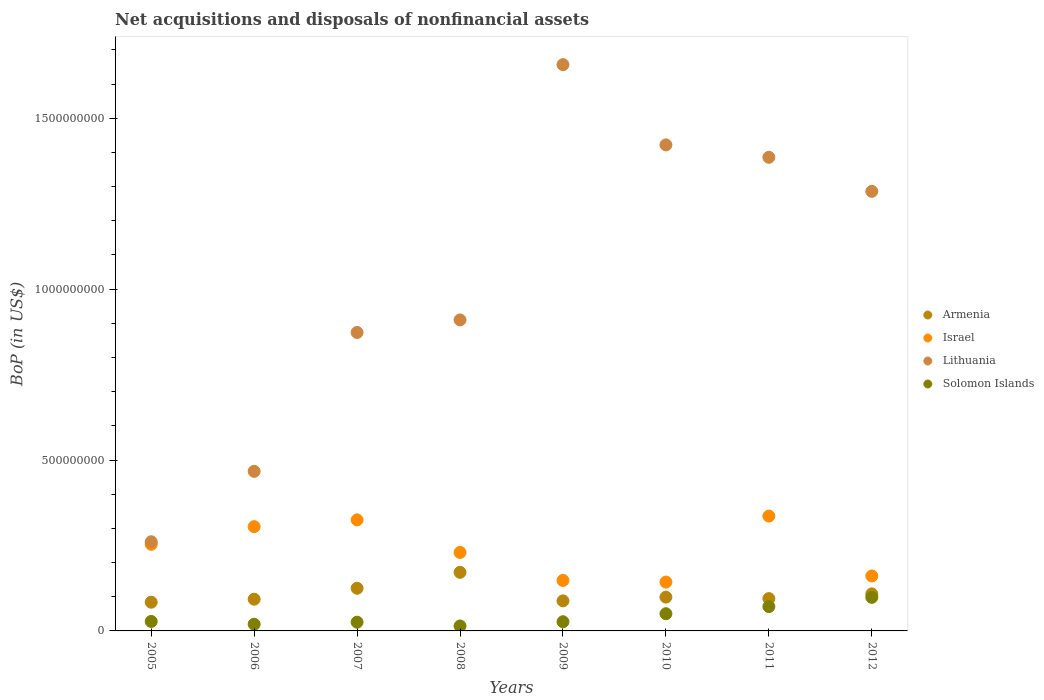What is the Balance of Payments in Solomon Islands in 2006?
Make the answer very short. 1.95e+07. Across all years, what is the maximum Balance of Payments in Armenia?
Your answer should be compact. 1.71e+08. Across all years, what is the minimum Balance of Payments in Lithuania?
Offer a very short reply. 2.61e+08. In which year was the Balance of Payments in Solomon Islands minimum?
Ensure brevity in your answer.  2008. What is the total Balance of Payments in Lithuania in the graph?
Provide a short and direct response. 8.26e+09. What is the difference between the Balance of Payments in Armenia in 2010 and that in 2011?
Offer a terse response. 4.26e+06. What is the difference between the Balance of Payments in Armenia in 2009 and the Balance of Payments in Solomon Islands in 2010?
Your answer should be compact. 3.76e+07. What is the average Balance of Payments in Lithuania per year?
Your answer should be very brief. 1.03e+09. In the year 2011, what is the difference between the Balance of Payments in Israel and Balance of Payments in Lithuania?
Provide a short and direct response. -1.05e+09. What is the ratio of the Balance of Payments in Armenia in 2009 to that in 2010?
Provide a succinct answer. 0.89. Is the Balance of Payments in Israel in 2009 less than that in 2011?
Provide a short and direct response. Yes. Is the difference between the Balance of Payments in Israel in 2007 and 2012 greater than the difference between the Balance of Payments in Lithuania in 2007 and 2012?
Make the answer very short. Yes. What is the difference between the highest and the second highest Balance of Payments in Armenia?
Your answer should be very brief. 4.66e+07. What is the difference between the highest and the lowest Balance of Payments in Israel?
Provide a succinct answer. 1.93e+08. Is it the case that in every year, the sum of the Balance of Payments in Lithuania and Balance of Payments in Solomon Islands  is greater than the sum of Balance of Payments in Israel and Balance of Payments in Armenia?
Provide a succinct answer. No. Is it the case that in every year, the sum of the Balance of Payments in Solomon Islands and Balance of Payments in Lithuania  is greater than the Balance of Payments in Israel?
Make the answer very short. Yes. Is the Balance of Payments in Solomon Islands strictly greater than the Balance of Payments in Armenia over the years?
Give a very brief answer. No. Is the Balance of Payments in Solomon Islands strictly less than the Balance of Payments in Israel over the years?
Keep it short and to the point. Yes. How many dotlines are there?
Give a very brief answer. 4. Are the values on the major ticks of Y-axis written in scientific E-notation?
Your response must be concise. No. What is the title of the graph?
Your answer should be compact. Net acquisitions and disposals of nonfinancial assets. Does "Turks and Caicos Islands" appear as one of the legend labels in the graph?
Keep it short and to the point. No. What is the label or title of the Y-axis?
Your answer should be very brief. BoP (in US$). What is the BoP (in US$) in Armenia in 2005?
Give a very brief answer. 8.40e+07. What is the BoP (in US$) of Israel in 2005?
Keep it short and to the point. 2.53e+08. What is the BoP (in US$) in Lithuania in 2005?
Provide a succinct answer. 2.61e+08. What is the BoP (in US$) of Solomon Islands in 2005?
Keep it short and to the point. 2.77e+07. What is the BoP (in US$) of Armenia in 2006?
Provide a succinct answer. 9.28e+07. What is the BoP (in US$) of Israel in 2006?
Your answer should be compact. 3.05e+08. What is the BoP (in US$) of Lithuania in 2006?
Your answer should be compact. 4.67e+08. What is the BoP (in US$) in Solomon Islands in 2006?
Keep it short and to the point. 1.95e+07. What is the BoP (in US$) of Armenia in 2007?
Ensure brevity in your answer.  1.25e+08. What is the BoP (in US$) of Israel in 2007?
Provide a short and direct response. 3.25e+08. What is the BoP (in US$) in Lithuania in 2007?
Provide a succinct answer. 8.73e+08. What is the BoP (in US$) of Solomon Islands in 2007?
Make the answer very short. 2.56e+07. What is the BoP (in US$) of Armenia in 2008?
Ensure brevity in your answer.  1.71e+08. What is the BoP (in US$) in Israel in 2008?
Your response must be concise. 2.30e+08. What is the BoP (in US$) in Lithuania in 2008?
Provide a succinct answer. 9.10e+08. What is the BoP (in US$) in Solomon Islands in 2008?
Your answer should be compact. 1.45e+07. What is the BoP (in US$) of Armenia in 2009?
Make the answer very short. 8.79e+07. What is the BoP (in US$) in Israel in 2009?
Offer a terse response. 1.48e+08. What is the BoP (in US$) in Lithuania in 2009?
Offer a very short reply. 1.66e+09. What is the BoP (in US$) in Solomon Islands in 2009?
Keep it short and to the point. 2.68e+07. What is the BoP (in US$) of Armenia in 2010?
Give a very brief answer. 9.89e+07. What is the BoP (in US$) of Israel in 2010?
Offer a terse response. 1.43e+08. What is the BoP (in US$) in Lithuania in 2010?
Give a very brief answer. 1.42e+09. What is the BoP (in US$) in Solomon Islands in 2010?
Provide a short and direct response. 5.03e+07. What is the BoP (in US$) of Armenia in 2011?
Your answer should be compact. 9.46e+07. What is the BoP (in US$) in Israel in 2011?
Your answer should be compact. 3.36e+08. What is the BoP (in US$) of Lithuania in 2011?
Make the answer very short. 1.39e+09. What is the BoP (in US$) in Solomon Islands in 2011?
Your answer should be very brief. 7.12e+07. What is the BoP (in US$) in Armenia in 2012?
Provide a succinct answer. 1.08e+08. What is the BoP (in US$) of Israel in 2012?
Keep it short and to the point. 1.61e+08. What is the BoP (in US$) in Lithuania in 2012?
Make the answer very short. 1.29e+09. What is the BoP (in US$) of Solomon Islands in 2012?
Offer a terse response. 9.82e+07. Across all years, what is the maximum BoP (in US$) of Armenia?
Your answer should be compact. 1.71e+08. Across all years, what is the maximum BoP (in US$) of Israel?
Your response must be concise. 3.36e+08. Across all years, what is the maximum BoP (in US$) of Lithuania?
Offer a terse response. 1.66e+09. Across all years, what is the maximum BoP (in US$) of Solomon Islands?
Keep it short and to the point. 9.82e+07. Across all years, what is the minimum BoP (in US$) in Armenia?
Make the answer very short. 8.40e+07. Across all years, what is the minimum BoP (in US$) of Israel?
Give a very brief answer. 1.43e+08. Across all years, what is the minimum BoP (in US$) in Lithuania?
Offer a terse response. 2.61e+08. Across all years, what is the minimum BoP (in US$) of Solomon Islands?
Your answer should be compact. 1.45e+07. What is the total BoP (in US$) in Armenia in the graph?
Your response must be concise. 8.63e+08. What is the total BoP (in US$) of Israel in the graph?
Ensure brevity in your answer.  1.90e+09. What is the total BoP (in US$) in Lithuania in the graph?
Make the answer very short. 8.26e+09. What is the total BoP (in US$) in Solomon Islands in the graph?
Your answer should be very brief. 3.34e+08. What is the difference between the BoP (in US$) of Armenia in 2005 and that in 2006?
Your answer should be compact. -8.81e+06. What is the difference between the BoP (in US$) of Israel in 2005 and that in 2006?
Offer a very short reply. -5.17e+07. What is the difference between the BoP (in US$) of Lithuania in 2005 and that in 2006?
Your answer should be very brief. -2.06e+08. What is the difference between the BoP (in US$) in Solomon Islands in 2005 and that in 2006?
Offer a very short reply. 8.20e+06. What is the difference between the BoP (in US$) in Armenia in 2005 and that in 2007?
Provide a short and direct response. -4.08e+07. What is the difference between the BoP (in US$) in Israel in 2005 and that in 2007?
Provide a short and direct response. -7.15e+07. What is the difference between the BoP (in US$) in Lithuania in 2005 and that in 2007?
Make the answer very short. -6.12e+08. What is the difference between the BoP (in US$) in Solomon Islands in 2005 and that in 2007?
Offer a terse response. 2.14e+06. What is the difference between the BoP (in US$) of Armenia in 2005 and that in 2008?
Your answer should be compact. -8.74e+07. What is the difference between the BoP (in US$) in Israel in 2005 and that in 2008?
Offer a terse response. 2.38e+07. What is the difference between the BoP (in US$) in Lithuania in 2005 and that in 2008?
Your response must be concise. -6.49e+08. What is the difference between the BoP (in US$) of Solomon Islands in 2005 and that in 2008?
Keep it short and to the point. 1.32e+07. What is the difference between the BoP (in US$) in Armenia in 2005 and that in 2009?
Offer a very short reply. -3.88e+06. What is the difference between the BoP (in US$) of Israel in 2005 and that in 2009?
Make the answer very short. 1.06e+08. What is the difference between the BoP (in US$) of Lithuania in 2005 and that in 2009?
Make the answer very short. -1.40e+09. What is the difference between the BoP (in US$) in Solomon Islands in 2005 and that in 2009?
Your answer should be compact. 8.91e+05. What is the difference between the BoP (in US$) of Armenia in 2005 and that in 2010?
Ensure brevity in your answer.  -1.49e+07. What is the difference between the BoP (in US$) of Israel in 2005 and that in 2010?
Give a very brief answer. 1.10e+08. What is the difference between the BoP (in US$) in Lithuania in 2005 and that in 2010?
Make the answer very short. -1.16e+09. What is the difference between the BoP (in US$) in Solomon Islands in 2005 and that in 2010?
Provide a succinct answer. -2.26e+07. What is the difference between the BoP (in US$) of Armenia in 2005 and that in 2011?
Your response must be concise. -1.06e+07. What is the difference between the BoP (in US$) of Israel in 2005 and that in 2011?
Your answer should be very brief. -8.26e+07. What is the difference between the BoP (in US$) of Lithuania in 2005 and that in 2011?
Make the answer very short. -1.12e+09. What is the difference between the BoP (in US$) of Solomon Islands in 2005 and that in 2011?
Give a very brief answer. -4.35e+07. What is the difference between the BoP (in US$) of Armenia in 2005 and that in 2012?
Offer a very short reply. -2.44e+07. What is the difference between the BoP (in US$) in Israel in 2005 and that in 2012?
Provide a succinct answer. 9.26e+07. What is the difference between the BoP (in US$) of Lithuania in 2005 and that in 2012?
Provide a short and direct response. -1.03e+09. What is the difference between the BoP (in US$) in Solomon Islands in 2005 and that in 2012?
Make the answer very short. -7.05e+07. What is the difference between the BoP (in US$) of Armenia in 2006 and that in 2007?
Give a very brief answer. -3.20e+07. What is the difference between the BoP (in US$) in Israel in 2006 and that in 2007?
Your response must be concise. -1.98e+07. What is the difference between the BoP (in US$) of Lithuania in 2006 and that in 2007?
Your answer should be very brief. -4.06e+08. What is the difference between the BoP (in US$) of Solomon Islands in 2006 and that in 2007?
Provide a short and direct response. -6.06e+06. What is the difference between the BoP (in US$) of Armenia in 2006 and that in 2008?
Keep it short and to the point. -7.86e+07. What is the difference between the BoP (in US$) in Israel in 2006 and that in 2008?
Keep it short and to the point. 7.55e+07. What is the difference between the BoP (in US$) of Lithuania in 2006 and that in 2008?
Your answer should be compact. -4.43e+08. What is the difference between the BoP (in US$) of Solomon Islands in 2006 and that in 2008?
Your response must be concise. 5.03e+06. What is the difference between the BoP (in US$) in Armenia in 2006 and that in 2009?
Provide a short and direct response. 4.93e+06. What is the difference between the BoP (in US$) of Israel in 2006 and that in 2009?
Offer a very short reply. 1.57e+08. What is the difference between the BoP (in US$) in Lithuania in 2006 and that in 2009?
Your response must be concise. -1.19e+09. What is the difference between the BoP (in US$) of Solomon Islands in 2006 and that in 2009?
Provide a succinct answer. -7.31e+06. What is the difference between the BoP (in US$) of Armenia in 2006 and that in 2010?
Make the answer very short. -6.05e+06. What is the difference between the BoP (in US$) of Israel in 2006 and that in 2010?
Keep it short and to the point. 1.62e+08. What is the difference between the BoP (in US$) of Lithuania in 2006 and that in 2010?
Ensure brevity in your answer.  -9.55e+08. What is the difference between the BoP (in US$) in Solomon Islands in 2006 and that in 2010?
Keep it short and to the point. -3.08e+07. What is the difference between the BoP (in US$) of Armenia in 2006 and that in 2011?
Provide a succinct answer. -1.79e+06. What is the difference between the BoP (in US$) in Israel in 2006 and that in 2011?
Offer a terse response. -3.09e+07. What is the difference between the BoP (in US$) of Lithuania in 2006 and that in 2011?
Your answer should be compact. -9.19e+08. What is the difference between the BoP (in US$) of Solomon Islands in 2006 and that in 2011?
Ensure brevity in your answer.  -5.17e+07. What is the difference between the BoP (in US$) in Armenia in 2006 and that in 2012?
Ensure brevity in your answer.  -1.56e+07. What is the difference between the BoP (in US$) in Israel in 2006 and that in 2012?
Ensure brevity in your answer.  1.44e+08. What is the difference between the BoP (in US$) in Lithuania in 2006 and that in 2012?
Your response must be concise. -8.19e+08. What is the difference between the BoP (in US$) of Solomon Islands in 2006 and that in 2012?
Provide a short and direct response. -7.87e+07. What is the difference between the BoP (in US$) of Armenia in 2007 and that in 2008?
Your answer should be compact. -4.66e+07. What is the difference between the BoP (in US$) of Israel in 2007 and that in 2008?
Keep it short and to the point. 9.53e+07. What is the difference between the BoP (in US$) of Lithuania in 2007 and that in 2008?
Keep it short and to the point. -3.67e+07. What is the difference between the BoP (in US$) in Solomon Islands in 2007 and that in 2008?
Your response must be concise. 1.11e+07. What is the difference between the BoP (in US$) of Armenia in 2007 and that in 2009?
Your answer should be very brief. 3.70e+07. What is the difference between the BoP (in US$) in Israel in 2007 and that in 2009?
Offer a terse response. 1.77e+08. What is the difference between the BoP (in US$) in Lithuania in 2007 and that in 2009?
Offer a very short reply. -7.84e+08. What is the difference between the BoP (in US$) of Solomon Islands in 2007 and that in 2009?
Your response must be concise. -1.24e+06. What is the difference between the BoP (in US$) in Armenia in 2007 and that in 2010?
Provide a short and direct response. 2.60e+07. What is the difference between the BoP (in US$) in Israel in 2007 and that in 2010?
Keep it short and to the point. 1.82e+08. What is the difference between the BoP (in US$) of Lithuania in 2007 and that in 2010?
Provide a succinct answer. -5.49e+08. What is the difference between the BoP (in US$) of Solomon Islands in 2007 and that in 2010?
Ensure brevity in your answer.  -2.47e+07. What is the difference between the BoP (in US$) of Armenia in 2007 and that in 2011?
Ensure brevity in your answer.  3.02e+07. What is the difference between the BoP (in US$) of Israel in 2007 and that in 2011?
Provide a short and direct response. -1.11e+07. What is the difference between the BoP (in US$) of Lithuania in 2007 and that in 2011?
Your response must be concise. -5.12e+08. What is the difference between the BoP (in US$) in Solomon Islands in 2007 and that in 2011?
Offer a very short reply. -4.56e+07. What is the difference between the BoP (in US$) of Armenia in 2007 and that in 2012?
Your answer should be very brief. 1.64e+07. What is the difference between the BoP (in US$) in Israel in 2007 and that in 2012?
Make the answer very short. 1.64e+08. What is the difference between the BoP (in US$) in Lithuania in 2007 and that in 2012?
Ensure brevity in your answer.  -4.13e+08. What is the difference between the BoP (in US$) in Solomon Islands in 2007 and that in 2012?
Offer a very short reply. -7.26e+07. What is the difference between the BoP (in US$) of Armenia in 2008 and that in 2009?
Your answer should be very brief. 8.36e+07. What is the difference between the BoP (in US$) of Israel in 2008 and that in 2009?
Your response must be concise. 8.19e+07. What is the difference between the BoP (in US$) in Lithuania in 2008 and that in 2009?
Make the answer very short. -7.47e+08. What is the difference between the BoP (in US$) in Solomon Islands in 2008 and that in 2009?
Your response must be concise. -1.23e+07. What is the difference between the BoP (in US$) in Armenia in 2008 and that in 2010?
Give a very brief answer. 7.26e+07. What is the difference between the BoP (in US$) of Israel in 2008 and that in 2010?
Your response must be concise. 8.67e+07. What is the difference between the BoP (in US$) in Lithuania in 2008 and that in 2010?
Make the answer very short. -5.12e+08. What is the difference between the BoP (in US$) of Solomon Islands in 2008 and that in 2010?
Provide a succinct answer. -3.58e+07. What is the difference between the BoP (in US$) of Armenia in 2008 and that in 2011?
Provide a short and direct response. 7.68e+07. What is the difference between the BoP (in US$) of Israel in 2008 and that in 2011?
Offer a very short reply. -1.06e+08. What is the difference between the BoP (in US$) in Lithuania in 2008 and that in 2011?
Provide a short and direct response. -4.76e+08. What is the difference between the BoP (in US$) in Solomon Islands in 2008 and that in 2011?
Offer a terse response. -5.67e+07. What is the difference between the BoP (in US$) of Armenia in 2008 and that in 2012?
Your answer should be compact. 6.30e+07. What is the difference between the BoP (in US$) of Israel in 2008 and that in 2012?
Provide a succinct answer. 6.88e+07. What is the difference between the BoP (in US$) in Lithuania in 2008 and that in 2012?
Keep it short and to the point. -3.76e+08. What is the difference between the BoP (in US$) in Solomon Islands in 2008 and that in 2012?
Make the answer very short. -8.37e+07. What is the difference between the BoP (in US$) in Armenia in 2009 and that in 2010?
Provide a short and direct response. -1.10e+07. What is the difference between the BoP (in US$) of Israel in 2009 and that in 2010?
Ensure brevity in your answer.  4.80e+06. What is the difference between the BoP (in US$) of Lithuania in 2009 and that in 2010?
Your response must be concise. 2.35e+08. What is the difference between the BoP (in US$) of Solomon Islands in 2009 and that in 2010?
Give a very brief answer. -2.35e+07. What is the difference between the BoP (in US$) in Armenia in 2009 and that in 2011?
Provide a short and direct response. -6.72e+06. What is the difference between the BoP (in US$) of Israel in 2009 and that in 2011?
Provide a succinct answer. -1.88e+08. What is the difference between the BoP (in US$) of Lithuania in 2009 and that in 2011?
Ensure brevity in your answer.  2.71e+08. What is the difference between the BoP (in US$) in Solomon Islands in 2009 and that in 2011?
Make the answer very short. -4.44e+07. What is the difference between the BoP (in US$) in Armenia in 2009 and that in 2012?
Provide a succinct answer. -2.05e+07. What is the difference between the BoP (in US$) in Israel in 2009 and that in 2012?
Offer a very short reply. -1.31e+07. What is the difference between the BoP (in US$) of Lithuania in 2009 and that in 2012?
Give a very brief answer. 3.71e+08. What is the difference between the BoP (in US$) of Solomon Islands in 2009 and that in 2012?
Your response must be concise. -7.14e+07. What is the difference between the BoP (in US$) of Armenia in 2010 and that in 2011?
Your answer should be very brief. 4.26e+06. What is the difference between the BoP (in US$) of Israel in 2010 and that in 2011?
Keep it short and to the point. -1.93e+08. What is the difference between the BoP (in US$) of Lithuania in 2010 and that in 2011?
Offer a very short reply. 3.64e+07. What is the difference between the BoP (in US$) in Solomon Islands in 2010 and that in 2011?
Give a very brief answer. -2.09e+07. What is the difference between the BoP (in US$) in Armenia in 2010 and that in 2012?
Give a very brief answer. -9.55e+06. What is the difference between the BoP (in US$) in Israel in 2010 and that in 2012?
Your answer should be compact. -1.79e+07. What is the difference between the BoP (in US$) in Lithuania in 2010 and that in 2012?
Your answer should be very brief. 1.36e+08. What is the difference between the BoP (in US$) in Solomon Islands in 2010 and that in 2012?
Offer a terse response. -4.79e+07. What is the difference between the BoP (in US$) of Armenia in 2011 and that in 2012?
Make the answer very short. -1.38e+07. What is the difference between the BoP (in US$) of Israel in 2011 and that in 2012?
Your answer should be very brief. 1.75e+08. What is the difference between the BoP (in US$) in Lithuania in 2011 and that in 2012?
Your answer should be very brief. 9.96e+07. What is the difference between the BoP (in US$) in Solomon Islands in 2011 and that in 2012?
Provide a succinct answer. -2.70e+07. What is the difference between the BoP (in US$) of Armenia in 2005 and the BoP (in US$) of Israel in 2006?
Your answer should be compact. -2.21e+08. What is the difference between the BoP (in US$) in Armenia in 2005 and the BoP (in US$) in Lithuania in 2006?
Your answer should be very brief. -3.83e+08. What is the difference between the BoP (in US$) of Armenia in 2005 and the BoP (in US$) of Solomon Islands in 2006?
Keep it short and to the point. 6.45e+07. What is the difference between the BoP (in US$) of Israel in 2005 and the BoP (in US$) of Lithuania in 2006?
Give a very brief answer. -2.14e+08. What is the difference between the BoP (in US$) in Israel in 2005 and the BoP (in US$) in Solomon Islands in 2006?
Offer a very short reply. 2.34e+08. What is the difference between the BoP (in US$) in Lithuania in 2005 and the BoP (in US$) in Solomon Islands in 2006?
Ensure brevity in your answer.  2.41e+08. What is the difference between the BoP (in US$) of Armenia in 2005 and the BoP (in US$) of Israel in 2007?
Make the answer very short. -2.41e+08. What is the difference between the BoP (in US$) in Armenia in 2005 and the BoP (in US$) in Lithuania in 2007?
Provide a succinct answer. -7.89e+08. What is the difference between the BoP (in US$) in Armenia in 2005 and the BoP (in US$) in Solomon Islands in 2007?
Provide a succinct answer. 5.84e+07. What is the difference between the BoP (in US$) in Israel in 2005 and the BoP (in US$) in Lithuania in 2007?
Give a very brief answer. -6.20e+08. What is the difference between the BoP (in US$) in Israel in 2005 and the BoP (in US$) in Solomon Islands in 2007?
Ensure brevity in your answer.  2.28e+08. What is the difference between the BoP (in US$) of Lithuania in 2005 and the BoP (in US$) of Solomon Islands in 2007?
Give a very brief answer. 2.35e+08. What is the difference between the BoP (in US$) in Armenia in 2005 and the BoP (in US$) in Israel in 2008?
Keep it short and to the point. -1.46e+08. What is the difference between the BoP (in US$) in Armenia in 2005 and the BoP (in US$) in Lithuania in 2008?
Your answer should be very brief. -8.26e+08. What is the difference between the BoP (in US$) of Armenia in 2005 and the BoP (in US$) of Solomon Islands in 2008?
Provide a short and direct response. 6.95e+07. What is the difference between the BoP (in US$) of Israel in 2005 and the BoP (in US$) of Lithuania in 2008?
Your answer should be compact. -6.57e+08. What is the difference between the BoP (in US$) in Israel in 2005 and the BoP (in US$) in Solomon Islands in 2008?
Give a very brief answer. 2.39e+08. What is the difference between the BoP (in US$) of Lithuania in 2005 and the BoP (in US$) of Solomon Islands in 2008?
Give a very brief answer. 2.46e+08. What is the difference between the BoP (in US$) in Armenia in 2005 and the BoP (in US$) in Israel in 2009?
Ensure brevity in your answer.  -6.37e+07. What is the difference between the BoP (in US$) in Armenia in 2005 and the BoP (in US$) in Lithuania in 2009?
Your answer should be compact. -1.57e+09. What is the difference between the BoP (in US$) in Armenia in 2005 and the BoP (in US$) in Solomon Islands in 2009?
Provide a short and direct response. 5.72e+07. What is the difference between the BoP (in US$) of Israel in 2005 and the BoP (in US$) of Lithuania in 2009?
Provide a succinct answer. -1.40e+09. What is the difference between the BoP (in US$) of Israel in 2005 and the BoP (in US$) of Solomon Islands in 2009?
Give a very brief answer. 2.27e+08. What is the difference between the BoP (in US$) of Lithuania in 2005 and the BoP (in US$) of Solomon Islands in 2009?
Provide a short and direct response. 2.34e+08. What is the difference between the BoP (in US$) in Armenia in 2005 and the BoP (in US$) in Israel in 2010?
Your response must be concise. -5.89e+07. What is the difference between the BoP (in US$) in Armenia in 2005 and the BoP (in US$) in Lithuania in 2010?
Give a very brief answer. -1.34e+09. What is the difference between the BoP (in US$) of Armenia in 2005 and the BoP (in US$) of Solomon Islands in 2010?
Offer a very short reply. 3.37e+07. What is the difference between the BoP (in US$) of Israel in 2005 and the BoP (in US$) of Lithuania in 2010?
Provide a succinct answer. -1.17e+09. What is the difference between the BoP (in US$) in Israel in 2005 and the BoP (in US$) in Solomon Islands in 2010?
Ensure brevity in your answer.  2.03e+08. What is the difference between the BoP (in US$) in Lithuania in 2005 and the BoP (in US$) in Solomon Islands in 2010?
Your response must be concise. 2.11e+08. What is the difference between the BoP (in US$) of Armenia in 2005 and the BoP (in US$) of Israel in 2011?
Offer a terse response. -2.52e+08. What is the difference between the BoP (in US$) of Armenia in 2005 and the BoP (in US$) of Lithuania in 2011?
Offer a very short reply. -1.30e+09. What is the difference between the BoP (in US$) of Armenia in 2005 and the BoP (in US$) of Solomon Islands in 2011?
Offer a very short reply. 1.28e+07. What is the difference between the BoP (in US$) of Israel in 2005 and the BoP (in US$) of Lithuania in 2011?
Provide a short and direct response. -1.13e+09. What is the difference between the BoP (in US$) of Israel in 2005 and the BoP (in US$) of Solomon Islands in 2011?
Keep it short and to the point. 1.82e+08. What is the difference between the BoP (in US$) in Lithuania in 2005 and the BoP (in US$) in Solomon Islands in 2011?
Offer a terse response. 1.90e+08. What is the difference between the BoP (in US$) in Armenia in 2005 and the BoP (in US$) in Israel in 2012?
Provide a succinct answer. -7.68e+07. What is the difference between the BoP (in US$) of Armenia in 2005 and the BoP (in US$) of Lithuania in 2012?
Your answer should be very brief. -1.20e+09. What is the difference between the BoP (in US$) of Armenia in 2005 and the BoP (in US$) of Solomon Islands in 2012?
Provide a succinct answer. -1.42e+07. What is the difference between the BoP (in US$) of Israel in 2005 and the BoP (in US$) of Lithuania in 2012?
Your answer should be compact. -1.03e+09. What is the difference between the BoP (in US$) in Israel in 2005 and the BoP (in US$) in Solomon Islands in 2012?
Give a very brief answer. 1.55e+08. What is the difference between the BoP (in US$) in Lithuania in 2005 and the BoP (in US$) in Solomon Islands in 2012?
Make the answer very short. 1.63e+08. What is the difference between the BoP (in US$) in Armenia in 2006 and the BoP (in US$) in Israel in 2007?
Provide a succinct answer. -2.32e+08. What is the difference between the BoP (in US$) in Armenia in 2006 and the BoP (in US$) in Lithuania in 2007?
Your answer should be very brief. -7.80e+08. What is the difference between the BoP (in US$) of Armenia in 2006 and the BoP (in US$) of Solomon Islands in 2007?
Offer a very short reply. 6.72e+07. What is the difference between the BoP (in US$) in Israel in 2006 and the BoP (in US$) in Lithuania in 2007?
Offer a terse response. -5.68e+08. What is the difference between the BoP (in US$) in Israel in 2006 and the BoP (in US$) in Solomon Islands in 2007?
Ensure brevity in your answer.  2.80e+08. What is the difference between the BoP (in US$) of Lithuania in 2006 and the BoP (in US$) of Solomon Islands in 2007?
Ensure brevity in your answer.  4.41e+08. What is the difference between the BoP (in US$) in Armenia in 2006 and the BoP (in US$) in Israel in 2008?
Make the answer very short. -1.37e+08. What is the difference between the BoP (in US$) in Armenia in 2006 and the BoP (in US$) in Lithuania in 2008?
Your response must be concise. -8.17e+08. What is the difference between the BoP (in US$) in Armenia in 2006 and the BoP (in US$) in Solomon Islands in 2008?
Your answer should be compact. 7.83e+07. What is the difference between the BoP (in US$) of Israel in 2006 and the BoP (in US$) of Lithuania in 2008?
Your answer should be compact. -6.05e+08. What is the difference between the BoP (in US$) in Israel in 2006 and the BoP (in US$) in Solomon Islands in 2008?
Provide a short and direct response. 2.91e+08. What is the difference between the BoP (in US$) in Lithuania in 2006 and the BoP (in US$) in Solomon Islands in 2008?
Make the answer very short. 4.52e+08. What is the difference between the BoP (in US$) of Armenia in 2006 and the BoP (in US$) of Israel in 2009?
Provide a succinct answer. -5.49e+07. What is the difference between the BoP (in US$) in Armenia in 2006 and the BoP (in US$) in Lithuania in 2009?
Keep it short and to the point. -1.56e+09. What is the difference between the BoP (in US$) in Armenia in 2006 and the BoP (in US$) in Solomon Islands in 2009?
Offer a very short reply. 6.60e+07. What is the difference between the BoP (in US$) of Israel in 2006 and the BoP (in US$) of Lithuania in 2009?
Your answer should be very brief. -1.35e+09. What is the difference between the BoP (in US$) of Israel in 2006 and the BoP (in US$) of Solomon Islands in 2009?
Keep it short and to the point. 2.78e+08. What is the difference between the BoP (in US$) in Lithuania in 2006 and the BoP (in US$) in Solomon Islands in 2009?
Offer a very short reply. 4.40e+08. What is the difference between the BoP (in US$) in Armenia in 2006 and the BoP (in US$) in Israel in 2010?
Provide a succinct answer. -5.01e+07. What is the difference between the BoP (in US$) of Armenia in 2006 and the BoP (in US$) of Lithuania in 2010?
Offer a terse response. -1.33e+09. What is the difference between the BoP (in US$) of Armenia in 2006 and the BoP (in US$) of Solomon Islands in 2010?
Make the answer very short. 4.25e+07. What is the difference between the BoP (in US$) of Israel in 2006 and the BoP (in US$) of Lithuania in 2010?
Your answer should be compact. -1.12e+09. What is the difference between the BoP (in US$) in Israel in 2006 and the BoP (in US$) in Solomon Islands in 2010?
Your answer should be compact. 2.55e+08. What is the difference between the BoP (in US$) of Lithuania in 2006 and the BoP (in US$) of Solomon Islands in 2010?
Keep it short and to the point. 4.17e+08. What is the difference between the BoP (in US$) of Armenia in 2006 and the BoP (in US$) of Israel in 2011?
Ensure brevity in your answer.  -2.43e+08. What is the difference between the BoP (in US$) in Armenia in 2006 and the BoP (in US$) in Lithuania in 2011?
Offer a terse response. -1.29e+09. What is the difference between the BoP (in US$) in Armenia in 2006 and the BoP (in US$) in Solomon Islands in 2011?
Your response must be concise. 2.16e+07. What is the difference between the BoP (in US$) in Israel in 2006 and the BoP (in US$) in Lithuania in 2011?
Your answer should be very brief. -1.08e+09. What is the difference between the BoP (in US$) in Israel in 2006 and the BoP (in US$) in Solomon Islands in 2011?
Your response must be concise. 2.34e+08. What is the difference between the BoP (in US$) of Lithuania in 2006 and the BoP (in US$) of Solomon Islands in 2011?
Offer a terse response. 3.96e+08. What is the difference between the BoP (in US$) in Armenia in 2006 and the BoP (in US$) in Israel in 2012?
Provide a succinct answer. -6.80e+07. What is the difference between the BoP (in US$) in Armenia in 2006 and the BoP (in US$) in Lithuania in 2012?
Your answer should be very brief. -1.19e+09. What is the difference between the BoP (in US$) of Armenia in 2006 and the BoP (in US$) of Solomon Islands in 2012?
Ensure brevity in your answer.  -5.39e+06. What is the difference between the BoP (in US$) of Israel in 2006 and the BoP (in US$) of Lithuania in 2012?
Give a very brief answer. -9.81e+08. What is the difference between the BoP (in US$) in Israel in 2006 and the BoP (in US$) in Solomon Islands in 2012?
Your response must be concise. 2.07e+08. What is the difference between the BoP (in US$) in Lithuania in 2006 and the BoP (in US$) in Solomon Islands in 2012?
Your answer should be compact. 3.69e+08. What is the difference between the BoP (in US$) of Armenia in 2007 and the BoP (in US$) of Israel in 2008?
Your answer should be compact. -1.05e+08. What is the difference between the BoP (in US$) in Armenia in 2007 and the BoP (in US$) in Lithuania in 2008?
Your answer should be very brief. -7.85e+08. What is the difference between the BoP (in US$) of Armenia in 2007 and the BoP (in US$) of Solomon Islands in 2008?
Give a very brief answer. 1.10e+08. What is the difference between the BoP (in US$) in Israel in 2007 and the BoP (in US$) in Lithuania in 2008?
Keep it short and to the point. -5.85e+08. What is the difference between the BoP (in US$) in Israel in 2007 and the BoP (in US$) in Solomon Islands in 2008?
Your response must be concise. 3.10e+08. What is the difference between the BoP (in US$) of Lithuania in 2007 and the BoP (in US$) of Solomon Islands in 2008?
Keep it short and to the point. 8.59e+08. What is the difference between the BoP (in US$) in Armenia in 2007 and the BoP (in US$) in Israel in 2009?
Your answer should be compact. -2.29e+07. What is the difference between the BoP (in US$) of Armenia in 2007 and the BoP (in US$) of Lithuania in 2009?
Provide a succinct answer. -1.53e+09. What is the difference between the BoP (in US$) in Armenia in 2007 and the BoP (in US$) in Solomon Islands in 2009?
Provide a short and direct response. 9.80e+07. What is the difference between the BoP (in US$) in Israel in 2007 and the BoP (in US$) in Lithuania in 2009?
Your answer should be compact. -1.33e+09. What is the difference between the BoP (in US$) of Israel in 2007 and the BoP (in US$) of Solomon Islands in 2009?
Keep it short and to the point. 2.98e+08. What is the difference between the BoP (in US$) in Lithuania in 2007 and the BoP (in US$) in Solomon Islands in 2009?
Provide a short and direct response. 8.46e+08. What is the difference between the BoP (in US$) in Armenia in 2007 and the BoP (in US$) in Israel in 2010?
Your answer should be very brief. -1.81e+07. What is the difference between the BoP (in US$) of Armenia in 2007 and the BoP (in US$) of Lithuania in 2010?
Ensure brevity in your answer.  -1.30e+09. What is the difference between the BoP (in US$) of Armenia in 2007 and the BoP (in US$) of Solomon Islands in 2010?
Keep it short and to the point. 7.45e+07. What is the difference between the BoP (in US$) of Israel in 2007 and the BoP (in US$) of Lithuania in 2010?
Offer a very short reply. -1.10e+09. What is the difference between the BoP (in US$) of Israel in 2007 and the BoP (in US$) of Solomon Islands in 2010?
Your response must be concise. 2.75e+08. What is the difference between the BoP (in US$) of Lithuania in 2007 and the BoP (in US$) of Solomon Islands in 2010?
Provide a short and direct response. 8.23e+08. What is the difference between the BoP (in US$) in Armenia in 2007 and the BoP (in US$) in Israel in 2011?
Your answer should be very brief. -2.11e+08. What is the difference between the BoP (in US$) in Armenia in 2007 and the BoP (in US$) in Lithuania in 2011?
Your answer should be compact. -1.26e+09. What is the difference between the BoP (in US$) in Armenia in 2007 and the BoP (in US$) in Solomon Islands in 2011?
Provide a succinct answer. 5.36e+07. What is the difference between the BoP (in US$) of Israel in 2007 and the BoP (in US$) of Lithuania in 2011?
Your response must be concise. -1.06e+09. What is the difference between the BoP (in US$) of Israel in 2007 and the BoP (in US$) of Solomon Islands in 2011?
Give a very brief answer. 2.54e+08. What is the difference between the BoP (in US$) in Lithuania in 2007 and the BoP (in US$) in Solomon Islands in 2011?
Keep it short and to the point. 8.02e+08. What is the difference between the BoP (in US$) of Armenia in 2007 and the BoP (in US$) of Israel in 2012?
Your response must be concise. -3.60e+07. What is the difference between the BoP (in US$) of Armenia in 2007 and the BoP (in US$) of Lithuania in 2012?
Offer a very short reply. -1.16e+09. What is the difference between the BoP (in US$) of Armenia in 2007 and the BoP (in US$) of Solomon Islands in 2012?
Offer a very short reply. 2.66e+07. What is the difference between the BoP (in US$) in Israel in 2007 and the BoP (in US$) in Lithuania in 2012?
Your answer should be very brief. -9.61e+08. What is the difference between the BoP (in US$) in Israel in 2007 and the BoP (in US$) in Solomon Islands in 2012?
Provide a succinct answer. 2.27e+08. What is the difference between the BoP (in US$) of Lithuania in 2007 and the BoP (in US$) of Solomon Islands in 2012?
Your answer should be compact. 7.75e+08. What is the difference between the BoP (in US$) of Armenia in 2008 and the BoP (in US$) of Israel in 2009?
Your answer should be very brief. 2.37e+07. What is the difference between the BoP (in US$) of Armenia in 2008 and the BoP (in US$) of Lithuania in 2009?
Keep it short and to the point. -1.49e+09. What is the difference between the BoP (in US$) of Armenia in 2008 and the BoP (in US$) of Solomon Islands in 2009?
Give a very brief answer. 1.45e+08. What is the difference between the BoP (in US$) in Israel in 2008 and the BoP (in US$) in Lithuania in 2009?
Your answer should be compact. -1.43e+09. What is the difference between the BoP (in US$) in Israel in 2008 and the BoP (in US$) in Solomon Islands in 2009?
Your answer should be compact. 2.03e+08. What is the difference between the BoP (in US$) of Lithuania in 2008 and the BoP (in US$) of Solomon Islands in 2009?
Give a very brief answer. 8.83e+08. What is the difference between the BoP (in US$) of Armenia in 2008 and the BoP (in US$) of Israel in 2010?
Provide a succinct answer. 2.85e+07. What is the difference between the BoP (in US$) of Armenia in 2008 and the BoP (in US$) of Lithuania in 2010?
Your answer should be compact. -1.25e+09. What is the difference between the BoP (in US$) of Armenia in 2008 and the BoP (in US$) of Solomon Islands in 2010?
Offer a terse response. 1.21e+08. What is the difference between the BoP (in US$) of Israel in 2008 and the BoP (in US$) of Lithuania in 2010?
Your answer should be compact. -1.19e+09. What is the difference between the BoP (in US$) in Israel in 2008 and the BoP (in US$) in Solomon Islands in 2010?
Offer a terse response. 1.79e+08. What is the difference between the BoP (in US$) in Lithuania in 2008 and the BoP (in US$) in Solomon Islands in 2010?
Your answer should be very brief. 8.60e+08. What is the difference between the BoP (in US$) of Armenia in 2008 and the BoP (in US$) of Israel in 2011?
Give a very brief answer. -1.65e+08. What is the difference between the BoP (in US$) in Armenia in 2008 and the BoP (in US$) in Lithuania in 2011?
Your answer should be compact. -1.21e+09. What is the difference between the BoP (in US$) in Armenia in 2008 and the BoP (in US$) in Solomon Islands in 2011?
Your answer should be very brief. 1.00e+08. What is the difference between the BoP (in US$) of Israel in 2008 and the BoP (in US$) of Lithuania in 2011?
Provide a short and direct response. -1.16e+09. What is the difference between the BoP (in US$) of Israel in 2008 and the BoP (in US$) of Solomon Islands in 2011?
Ensure brevity in your answer.  1.58e+08. What is the difference between the BoP (in US$) in Lithuania in 2008 and the BoP (in US$) in Solomon Islands in 2011?
Give a very brief answer. 8.39e+08. What is the difference between the BoP (in US$) in Armenia in 2008 and the BoP (in US$) in Israel in 2012?
Give a very brief answer. 1.06e+07. What is the difference between the BoP (in US$) in Armenia in 2008 and the BoP (in US$) in Lithuania in 2012?
Make the answer very short. -1.11e+09. What is the difference between the BoP (in US$) of Armenia in 2008 and the BoP (in US$) of Solomon Islands in 2012?
Provide a short and direct response. 7.32e+07. What is the difference between the BoP (in US$) in Israel in 2008 and the BoP (in US$) in Lithuania in 2012?
Your answer should be compact. -1.06e+09. What is the difference between the BoP (in US$) of Israel in 2008 and the BoP (in US$) of Solomon Islands in 2012?
Offer a terse response. 1.31e+08. What is the difference between the BoP (in US$) of Lithuania in 2008 and the BoP (in US$) of Solomon Islands in 2012?
Ensure brevity in your answer.  8.12e+08. What is the difference between the BoP (in US$) in Armenia in 2009 and the BoP (in US$) in Israel in 2010?
Offer a terse response. -5.50e+07. What is the difference between the BoP (in US$) of Armenia in 2009 and the BoP (in US$) of Lithuania in 2010?
Provide a short and direct response. -1.33e+09. What is the difference between the BoP (in US$) in Armenia in 2009 and the BoP (in US$) in Solomon Islands in 2010?
Make the answer very short. 3.76e+07. What is the difference between the BoP (in US$) in Israel in 2009 and the BoP (in US$) in Lithuania in 2010?
Provide a short and direct response. -1.27e+09. What is the difference between the BoP (in US$) of Israel in 2009 and the BoP (in US$) of Solomon Islands in 2010?
Offer a very short reply. 9.74e+07. What is the difference between the BoP (in US$) in Lithuania in 2009 and the BoP (in US$) in Solomon Islands in 2010?
Make the answer very short. 1.61e+09. What is the difference between the BoP (in US$) in Armenia in 2009 and the BoP (in US$) in Israel in 2011?
Offer a terse response. -2.48e+08. What is the difference between the BoP (in US$) of Armenia in 2009 and the BoP (in US$) of Lithuania in 2011?
Make the answer very short. -1.30e+09. What is the difference between the BoP (in US$) in Armenia in 2009 and the BoP (in US$) in Solomon Islands in 2011?
Offer a very short reply. 1.67e+07. What is the difference between the BoP (in US$) in Israel in 2009 and the BoP (in US$) in Lithuania in 2011?
Ensure brevity in your answer.  -1.24e+09. What is the difference between the BoP (in US$) of Israel in 2009 and the BoP (in US$) of Solomon Islands in 2011?
Your answer should be very brief. 7.65e+07. What is the difference between the BoP (in US$) in Lithuania in 2009 and the BoP (in US$) in Solomon Islands in 2011?
Your answer should be very brief. 1.59e+09. What is the difference between the BoP (in US$) of Armenia in 2009 and the BoP (in US$) of Israel in 2012?
Your answer should be compact. -7.29e+07. What is the difference between the BoP (in US$) in Armenia in 2009 and the BoP (in US$) in Lithuania in 2012?
Ensure brevity in your answer.  -1.20e+09. What is the difference between the BoP (in US$) in Armenia in 2009 and the BoP (in US$) in Solomon Islands in 2012?
Ensure brevity in your answer.  -1.03e+07. What is the difference between the BoP (in US$) in Israel in 2009 and the BoP (in US$) in Lithuania in 2012?
Ensure brevity in your answer.  -1.14e+09. What is the difference between the BoP (in US$) of Israel in 2009 and the BoP (in US$) of Solomon Islands in 2012?
Your answer should be very brief. 4.95e+07. What is the difference between the BoP (in US$) in Lithuania in 2009 and the BoP (in US$) in Solomon Islands in 2012?
Offer a very short reply. 1.56e+09. What is the difference between the BoP (in US$) of Armenia in 2010 and the BoP (in US$) of Israel in 2011?
Ensure brevity in your answer.  -2.37e+08. What is the difference between the BoP (in US$) in Armenia in 2010 and the BoP (in US$) in Lithuania in 2011?
Provide a succinct answer. -1.29e+09. What is the difference between the BoP (in US$) in Armenia in 2010 and the BoP (in US$) in Solomon Islands in 2011?
Your answer should be compact. 2.77e+07. What is the difference between the BoP (in US$) of Israel in 2010 and the BoP (in US$) of Lithuania in 2011?
Offer a very short reply. -1.24e+09. What is the difference between the BoP (in US$) in Israel in 2010 and the BoP (in US$) in Solomon Islands in 2011?
Keep it short and to the point. 7.17e+07. What is the difference between the BoP (in US$) in Lithuania in 2010 and the BoP (in US$) in Solomon Islands in 2011?
Offer a terse response. 1.35e+09. What is the difference between the BoP (in US$) in Armenia in 2010 and the BoP (in US$) in Israel in 2012?
Keep it short and to the point. -6.19e+07. What is the difference between the BoP (in US$) in Armenia in 2010 and the BoP (in US$) in Lithuania in 2012?
Your response must be concise. -1.19e+09. What is the difference between the BoP (in US$) in Armenia in 2010 and the BoP (in US$) in Solomon Islands in 2012?
Offer a terse response. 6.59e+05. What is the difference between the BoP (in US$) of Israel in 2010 and the BoP (in US$) of Lithuania in 2012?
Offer a terse response. -1.14e+09. What is the difference between the BoP (in US$) of Israel in 2010 and the BoP (in US$) of Solomon Islands in 2012?
Provide a succinct answer. 4.47e+07. What is the difference between the BoP (in US$) in Lithuania in 2010 and the BoP (in US$) in Solomon Islands in 2012?
Your response must be concise. 1.32e+09. What is the difference between the BoP (in US$) of Armenia in 2011 and the BoP (in US$) of Israel in 2012?
Offer a very short reply. -6.62e+07. What is the difference between the BoP (in US$) of Armenia in 2011 and the BoP (in US$) of Lithuania in 2012?
Provide a succinct answer. -1.19e+09. What is the difference between the BoP (in US$) in Armenia in 2011 and the BoP (in US$) in Solomon Islands in 2012?
Keep it short and to the point. -3.60e+06. What is the difference between the BoP (in US$) of Israel in 2011 and the BoP (in US$) of Lithuania in 2012?
Your answer should be compact. -9.50e+08. What is the difference between the BoP (in US$) in Israel in 2011 and the BoP (in US$) in Solomon Islands in 2012?
Provide a short and direct response. 2.38e+08. What is the difference between the BoP (in US$) in Lithuania in 2011 and the BoP (in US$) in Solomon Islands in 2012?
Your response must be concise. 1.29e+09. What is the average BoP (in US$) of Armenia per year?
Keep it short and to the point. 1.08e+08. What is the average BoP (in US$) in Israel per year?
Make the answer very short. 2.38e+08. What is the average BoP (in US$) in Lithuania per year?
Your answer should be compact. 1.03e+09. What is the average BoP (in US$) of Solomon Islands per year?
Offer a terse response. 4.17e+07. In the year 2005, what is the difference between the BoP (in US$) in Armenia and BoP (in US$) in Israel?
Your answer should be very brief. -1.69e+08. In the year 2005, what is the difference between the BoP (in US$) of Armenia and BoP (in US$) of Lithuania?
Your response must be concise. -1.77e+08. In the year 2005, what is the difference between the BoP (in US$) of Armenia and BoP (in US$) of Solomon Islands?
Offer a very short reply. 5.63e+07. In the year 2005, what is the difference between the BoP (in US$) of Israel and BoP (in US$) of Lithuania?
Keep it short and to the point. -7.48e+06. In the year 2005, what is the difference between the BoP (in US$) of Israel and BoP (in US$) of Solomon Islands?
Keep it short and to the point. 2.26e+08. In the year 2005, what is the difference between the BoP (in US$) in Lithuania and BoP (in US$) in Solomon Islands?
Provide a short and direct response. 2.33e+08. In the year 2006, what is the difference between the BoP (in US$) of Armenia and BoP (in US$) of Israel?
Give a very brief answer. -2.12e+08. In the year 2006, what is the difference between the BoP (in US$) in Armenia and BoP (in US$) in Lithuania?
Ensure brevity in your answer.  -3.74e+08. In the year 2006, what is the difference between the BoP (in US$) of Armenia and BoP (in US$) of Solomon Islands?
Your answer should be compact. 7.33e+07. In the year 2006, what is the difference between the BoP (in US$) in Israel and BoP (in US$) in Lithuania?
Your answer should be very brief. -1.62e+08. In the year 2006, what is the difference between the BoP (in US$) of Israel and BoP (in US$) of Solomon Islands?
Make the answer very short. 2.86e+08. In the year 2006, what is the difference between the BoP (in US$) of Lithuania and BoP (in US$) of Solomon Islands?
Make the answer very short. 4.47e+08. In the year 2007, what is the difference between the BoP (in US$) in Armenia and BoP (in US$) in Israel?
Give a very brief answer. -2.00e+08. In the year 2007, what is the difference between the BoP (in US$) in Armenia and BoP (in US$) in Lithuania?
Give a very brief answer. -7.48e+08. In the year 2007, what is the difference between the BoP (in US$) in Armenia and BoP (in US$) in Solomon Islands?
Keep it short and to the point. 9.92e+07. In the year 2007, what is the difference between the BoP (in US$) of Israel and BoP (in US$) of Lithuania?
Provide a succinct answer. -5.48e+08. In the year 2007, what is the difference between the BoP (in US$) in Israel and BoP (in US$) in Solomon Islands?
Keep it short and to the point. 2.99e+08. In the year 2007, what is the difference between the BoP (in US$) in Lithuania and BoP (in US$) in Solomon Islands?
Make the answer very short. 8.48e+08. In the year 2008, what is the difference between the BoP (in US$) of Armenia and BoP (in US$) of Israel?
Make the answer very short. -5.82e+07. In the year 2008, what is the difference between the BoP (in US$) of Armenia and BoP (in US$) of Lithuania?
Offer a very short reply. -7.39e+08. In the year 2008, what is the difference between the BoP (in US$) in Armenia and BoP (in US$) in Solomon Islands?
Offer a very short reply. 1.57e+08. In the year 2008, what is the difference between the BoP (in US$) in Israel and BoP (in US$) in Lithuania?
Your response must be concise. -6.80e+08. In the year 2008, what is the difference between the BoP (in US$) of Israel and BoP (in US$) of Solomon Islands?
Provide a short and direct response. 2.15e+08. In the year 2008, what is the difference between the BoP (in US$) of Lithuania and BoP (in US$) of Solomon Islands?
Offer a terse response. 8.95e+08. In the year 2009, what is the difference between the BoP (in US$) of Armenia and BoP (in US$) of Israel?
Make the answer very short. -5.98e+07. In the year 2009, what is the difference between the BoP (in US$) of Armenia and BoP (in US$) of Lithuania?
Offer a very short reply. -1.57e+09. In the year 2009, what is the difference between the BoP (in US$) in Armenia and BoP (in US$) in Solomon Islands?
Your answer should be very brief. 6.10e+07. In the year 2009, what is the difference between the BoP (in US$) of Israel and BoP (in US$) of Lithuania?
Provide a short and direct response. -1.51e+09. In the year 2009, what is the difference between the BoP (in US$) of Israel and BoP (in US$) of Solomon Islands?
Your answer should be very brief. 1.21e+08. In the year 2009, what is the difference between the BoP (in US$) of Lithuania and BoP (in US$) of Solomon Islands?
Make the answer very short. 1.63e+09. In the year 2010, what is the difference between the BoP (in US$) of Armenia and BoP (in US$) of Israel?
Ensure brevity in your answer.  -4.40e+07. In the year 2010, what is the difference between the BoP (in US$) in Armenia and BoP (in US$) in Lithuania?
Keep it short and to the point. -1.32e+09. In the year 2010, what is the difference between the BoP (in US$) in Armenia and BoP (in US$) in Solomon Islands?
Your response must be concise. 4.86e+07. In the year 2010, what is the difference between the BoP (in US$) of Israel and BoP (in US$) of Lithuania?
Provide a short and direct response. -1.28e+09. In the year 2010, what is the difference between the BoP (in US$) in Israel and BoP (in US$) in Solomon Islands?
Provide a short and direct response. 9.26e+07. In the year 2010, what is the difference between the BoP (in US$) of Lithuania and BoP (in US$) of Solomon Islands?
Offer a terse response. 1.37e+09. In the year 2011, what is the difference between the BoP (in US$) in Armenia and BoP (in US$) in Israel?
Give a very brief answer. -2.41e+08. In the year 2011, what is the difference between the BoP (in US$) of Armenia and BoP (in US$) of Lithuania?
Your answer should be compact. -1.29e+09. In the year 2011, what is the difference between the BoP (in US$) in Armenia and BoP (in US$) in Solomon Islands?
Provide a short and direct response. 2.34e+07. In the year 2011, what is the difference between the BoP (in US$) of Israel and BoP (in US$) of Lithuania?
Provide a succinct answer. -1.05e+09. In the year 2011, what is the difference between the BoP (in US$) of Israel and BoP (in US$) of Solomon Islands?
Your answer should be compact. 2.65e+08. In the year 2011, what is the difference between the BoP (in US$) of Lithuania and BoP (in US$) of Solomon Islands?
Ensure brevity in your answer.  1.31e+09. In the year 2012, what is the difference between the BoP (in US$) of Armenia and BoP (in US$) of Israel?
Offer a terse response. -5.24e+07. In the year 2012, what is the difference between the BoP (in US$) of Armenia and BoP (in US$) of Lithuania?
Offer a very short reply. -1.18e+09. In the year 2012, what is the difference between the BoP (in US$) of Armenia and BoP (in US$) of Solomon Islands?
Your answer should be compact. 1.02e+07. In the year 2012, what is the difference between the BoP (in US$) in Israel and BoP (in US$) in Lithuania?
Give a very brief answer. -1.13e+09. In the year 2012, what is the difference between the BoP (in US$) in Israel and BoP (in US$) in Solomon Islands?
Make the answer very short. 6.26e+07. In the year 2012, what is the difference between the BoP (in US$) in Lithuania and BoP (in US$) in Solomon Islands?
Your answer should be compact. 1.19e+09. What is the ratio of the BoP (in US$) in Armenia in 2005 to that in 2006?
Offer a very short reply. 0.91. What is the ratio of the BoP (in US$) in Israel in 2005 to that in 2006?
Your answer should be very brief. 0.83. What is the ratio of the BoP (in US$) in Lithuania in 2005 to that in 2006?
Provide a succinct answer. 0.56. What is the ratio of the BoP (in US$) of Solomon Islands in 2005 to that in 2006?
Your answer should be compact. 1.42. What is the ratio of the BoP (in US$) of Armenia in 2005 to that in 2007?
Offer a very short reply. 0.67. What is the ratio of the BoP (in US$) of Israel in 2005 to that in 2007?
Make the answer very short. 0.78. What is the ratio of the BoP (in US$) of Lithuania in 2005 to that in 2007?
Keep it short and to the point. 0.3. What is the ratio of the BoP (in US$) in Solomon Islands in 2005 to that in 2007?
Provide a succinct answer. 1.08. What is the ratio of the BoP (in US$) of Armenia in 2005 to that in 2008?
Provide a short and direct response. 0.49. What is the ratio of the BoP (in US$) in Israel in 2005 to that in 2008?
Provide a short and direct response. 1.1. What is the ratio of the BoP (in US$) of Lithuania in 2005 to that in 2008?
Make the answer very short. 0.29. What is the ratio of the BoP (in US$) of Solomon Islands in 2005 to that in 2008?
Offer a terse response. 1.91. What is the ratio of the BoP (in US$) of Armenia in 2005 to that in 2009?
Keep it short and to the point. 0.96. What is the ratio of the BoP (in US$) in Israel in 2005 to that in 2009?
Your answer should be compact. 1.72. What is the ratio of the BoP (in US$) of Lithuania in 2005 to that in 2009?
Make the answer very short. 0.16. What is the ratio of the BoP (in US$) in Solomon Islands in 2005 to that in 2009?
Ensure brevity in your answer.  1.03. What is the ratio of the BoP (in US$) in Armenia in 2005 to that in 2010?
Your response must be concise. 0.85. What is the ratio of the BoP (in US$) in Israel in 2005 to that in 2010?
Keep it short and to the point. 1.77. What is the ratio of the BoP (in US$) of Lithuania in 2005 to that in 2010?
Ensure brevity in your answer.  0.18. What is the ratio of the BoP (in US$) in Solomon Islands in 2005 to that in 2010?
Give a very brief answer. 0.55. What is the ratio of the BoP (in US$) in Armenia in 2005 to that in 2011?
Ensure brevity in your answer.  0.89. What is the ratio of the BoP (in US$) of Israel in 2005 to that in 2011?
Offer a very short reply. 0.75. What is the ratio of the BoP (in US$) of Lithuania in 2005 to that in 2011?
Make the answer very short. 0.19. What is the ratio of the BoP (in US$) of Solomon Islands in 2005 to that in 2011?
Give a very brief answer. 0.39. What is the ratio of the BoP (in US$) of Armenia in 2005 to that in 2012?
Offer a very short reply. 0.77. What is the ratio of the BoP (in US$) in Israel in 2005 to that in 2012?
Provide a short and direct response. 1.58. What is the ratio of the BoP (in US$) in Lithuania in 2005 to that in 2012?
Offer a terse response. 0.2. What is the ratio of the BoP (in US$) in Solomon Islands in 2005 to that in 2012?
Make the answer very short. 0.28. What is the ratio of the BoP (in US$) of Armenia in 2006 to that in 2007?
Ensure brevity in your answer.  0.74. What is the ratio of the BoP (in US$) of Israel in 2006 to that in 2007?
Give a very brief answer. 0.94. What is the ratio of the BoP (in US$) of Lithuania in 2006 to that in 2007?
Provide a succinct answer. 0.53. What is the ratio of the BoP (in US$) in Solomon Islands in 2006 to that in 2007?
Provide a succinct answer. 0.76. What is the ratio of the BoP (in US$) of Armenia in 2006 to that in 2008?
Keep it short and to the point. 0.54. What is the ratio of the BoP (in US$) in Israel in 2006 to that in 2008?
Provide a short and direct response. 1.33. What is the ratio of the BoP (in US$) of Lithuania in 2006 to that in 2008?
Provide a short and direct response. 0.51. What is the ratio of the BoP (in US$) in Solomon Islands in 2006 to that in 2008?
Your answer should be compact. 1.35. What is the ratio of the BoP (in US$) of Armenia in 2006 to that in 2009?
Make the answer very short. 1.06. What is the ratio of the BoP (in US$) of Israel in 2006 to that in 2009?
Your response must be concise. 2.07. What is the ratio of the BoP (in US$) of Lithuania in 2006 to that in 2009?
Make the answer very short. 0.28. What is the ratio of the BoP (in US$) of Solomon Islands in 2006 to that in 2009?
Make the answer very short. 0.73. What is the ratio of the BoP (in US$) in Armenia in 2006 to that in 2010?
Make the answer very short. 0.94. What is the ratio of the BoP (in US$) of Israel in 2006 to that in 2010?
Provide a short and direct response. 2.14. What is the ratio of the BoP (in US$) in Lithuania in 2006 to that in 2010?
Give a very brief answer. 0.33. What is the ratio of the BoP (in US$) of Solomon Islands in 2006 to that in 2010?
Make the answer very short. 0.39. What is the ratio of the BoP (in US$) in Armenia in 2006 to that in 2011?
Keep it short and to the point. 0.98. What is the ratio of the BoP (in US$) in Israel in 2006 to that in 2011?
Offer a terse response. 0.91. What is the ratio of the BoP (in US$) of Lithuania in 2006 to that in 2011?
Provide a succinct answer. 0.34. What is the ratio of the BoP (in US$) in Solomon Islands in 2006 to that in 2011?
Provide a short and direct response. 0.27. What is the ratio of the BoP (in US$) in Armenia in 2006 to that in 2012?
Offer a very short reply. 0.86. What is the ratio of the BoP (in US$) of Israel in 2006 to that in 2012?
Provide a succinct answer. 1.9. What is the ratio of the BoP (in US$) of Lithuania in 2006 to that in 2012?
Your answer should be compact. 0.36. What is the ratio of the BoP (in US$) in Solomon Islands in 2006 to that in 2012?
Your answer should be compact. 0.2. What is the ratio of the BoP (in US$) in Armenia in 2007 to that in 2008?
Ensure brevity in your answer.  0.73. What is the ratio of the BoP (in US$) of Israel in 2007 to that in 2008?
Your answer should be compact. 1.42. What is the ratio of the BoP (in US$) in Lithuania in 2007 to that in 2008?
Make the answer very short. 0.96. What is the ratio of the BoP (in US$) in Solomon Islands in 2007 to that in 2008?
Your response must be concise. 1.76. What is the ratio of the BoP (in US$) of Armenia in 2007 to that in 2009?
Offer a terse response. 1.42. What is the ratio of the BoP (in US$) in Israel in 2007 to that in 2009?
Make the answer very short. 2.2. What is the ratio of the BoP (in US$) in Lithuania in 2007 to that in 2009?
Make the answer very short. 0.53. What is the ratio of the BoP (in US$) in Solomon Islands in 2007 to that in 2009?
Make the answer very short. 0.95. What is the ratio of the BoP (in US$) in Armenia in 2007 to that in 2010?
Ensure brevity in your answer.  1.26. What is the ratio of the BoP (in US$) of Israel in 2007 to that in 2010?
Provide a short and direct response. 2.27. What is the ratio of the BoP (in US$) in Lithuania in 2007 to that in 2010?
Offer a very short reply. 0.61. What is the ratio of the BoP (in US$) of Solomon Islands in 2007 to that in 2010?
Offer a very short reply. 0.51. What is the ratio of the BoP (in US$) in Armenia in 2007 to that in 2011?
Give a very brief answer. 1.32. What is the ratio of the BoP (in US$) in Lithuania in 2007 to that in 2011?
Offer a terse response. 0.63. What is the ratio of the BoP (in US$) in Solomon Islands in 2007 to that in 2011?
Provide a succinct answer. 0.36. What is the ratio of the BoP (in US$) in Armenia in 2007 to that in 2012?
Your answer should be very brief. 1.15. What is the ratio of the BoP (in US$) of Israel in 2007 to that in 2012?
Give a very brief answer. 2.02. What is the ratio of the BoP (in US$) of Lithuania in 2007 to that in 2012?
Provide a succinct answer. 0.68. What is the ratio of the BoP (in US$) of Solomon Islands in 2007 to that in 2012?
Your answer should be compact. 0.26. What is the ratio of the BoP (in US$) in Armenia in 2008 to that in 2009?
Provide a succinct answer. 1.95. What is the ratio of the BoP (in US$) in Israel in 2008 to that in 2009?
Give a very brief answer. 1.55. What is the ratio of the BoP (in US$) of Lithuania in 2008 to that in 2009?
Your answer should be compact. 0.55. What is the ratio of the BoP (in US$) of Solomon Islands in 2008 to that in 2009?
Make the answer very short. 0.54. What is the ratio of the BoP (in US$) in Armenia in 2008 to that in 2010?
Provide a short and direct response. 1.73. What is the ratio of the BoP (in US$) in Israel in 2008 to that in 2010?
Make the answer very short. 1.61. What is the ratio of the BoP (in US$) in Lithuania in 2008 to that in 2010?
Your answer should be compact. 0.64. What is the ratio of the BoP (in US$) of Solomon Islands in 2008 to that in 2010?
Your answer should be compact. 0.29. What is the ratio of the BoP (in US$) in Armenia in 2008 to that in 2011?
Your answer should be very brief. 1.81. What is the ratio of the BoP (in US$) of Israel in 2008 to that in 2011?
Make the answer very short. 0.68. What is the ratio of the BoP (in US$) in Lithuania in 2008 to that in 2011?
Your response must be concise. 0.66. What is the ratio of the BoP (in US$) of Solomon Islands in 2008 to that in 2011?
Your answer should be very brief. 0.2. What is the ratio of the BoP (in US$) in Armenia in 2008 to that in 2012?
Make the answer very short. 1.58. What is the ratio of the BoP (in US$) in Israel in 2008 to that in 2012?
Make the answer very short. 1.43. What is the ratio of the BoP (in US$) in Lithuania in 2008 to that in 2012?
Give a very brief answer. 0.71. What is the ratio of the BoP (in US$) in Solomon Islands in 2008 to that in 2012?
Keep it short and to the point. 0.15. What is the ratio of the BoP (in US$) in Israel in 2009 to that in 2010?
Keep it short and to the point. 1.03. What is the ratio of the BoP (in US$) in Lithuania in 2009 to that in 2010?
Offer a terse response. 1.17. What is the ratio of the BoP (in US$) of Solomon Islands in 2009 to that in 2010?
Offer a terse response. 0.53. What is the ratio of the BoP (in US$) in Armenia in 2009 to that in 2011?
Offer a terse response. 0.93. What is the ratio of the BoP (in US$) in Israel in 2009 to that in 2011?
Provide a succinct answer. 0.44. What is the ratio of the BoP (in US$) in Lithuania in 2009 to that in 2011?
Offer a terse response. 1.2. What is the ratio of the BoP (in US$) in Solomon Islands in 2009 to that in 2011?
Ensure brevity in your answer.  0.38. What is the ratio of the BoP (in US$) in Armenia in 2009 to that in 2012?
Provide a succinct answer. 0.81. What is the ratio of the BoP (in US$) of Israel in 2009 to that in 2012?
Make the answer very short. 0.92. What is the ratio of the BoP (in US$) in Lithuania in 2009 to that in 2012?
Keep it short and to the point. 1.29. What is the ratio of the BoP (in US$) in Solomon Islands in 2009 to that in 2012?
Provide a short and direct response. 0.27. What is the ratio of the BoP (in US$) of Armenia in 2010 to that in 2011?
Offer a very short reply. 1.04. What is the ratio of the BoP (in US$) of Israel in 2010 to that in 2011?
Keep it short and to the point. 0.43. What is the ratio of the BoP (in US$) of Lithuania in 2010 to that in 2011?
Your response must be concise. 1.03. What is the ratio of the BoP (in US$) of Solomon Islands in 2010 to that in 2011?
Offer a very short reply. 0.71. What is the ratio of the BoP (in US$) of Armenia in 2010 to that in 2012?
Give a very brief answer. 0.91. What is the ratio of the BoP (in US$) of Israel in 2010 to that in 2012?
Keep it short and to the point. 0.89. What is the ratio of the BoP (in US$) of Lithuania in 2010 to that in 2012?
Your answer should be very brief. 1.11. What is the ratio of the BoP (in US$) in Solomon Islands in 2010 to that in 2012?
Your answer should be compact. 0.51. What is the ratio of the BoP (in US$) of Armenia in 2011 to that in 2012?
Ensure brevity in your answer.  0.87. What is the ratio of the BoP (in US$) of Israel in 2011 to that in 2012?
Offer a terse response. 2.09. What is the ratio of the BoP (in US$) in Lithuania in 2011 to that in 2012?
Make the answer very short. 1.08. What is the ratio of the BoP (in US$) of Solomon Islands in 2011 to that in 2012?
Your answer should be compact. 0.73. What is the difference between the highest and the second highest BoP (in US$) in Armenia?
Your answer should be very brief. 4.66e+07. What is the difference between the highest and the second highest BoP (in US$) of Israel?
Your response must be concise. 1.11e+07. What is the difference between the highest and the second highest BoP (in US$) in Lithuania?
Keep it short and to the point. 2.35e+08. What is the difference between the highest and the second highest BoP (in US$) of Solomon Islands?
Offer a terse response. 2.70e+07. What is the difference between the highest and the lowest BoP (in US$) of Armenia?
Your response must be concise. 8.74e+07. What is the difference between the highest and the lowest BoP (in US$) in Israel?
Offer a terse response. 1.93e+08. What is the difference between the highest and the lowest BoP (in US$) in Lithuania?
Provide a succinct answer. 1.40e+09. What is the difference between the highest and the lowest BoP (in US$) of Solomon Islands?
Keep it short and to the point. 8.37e+07. 